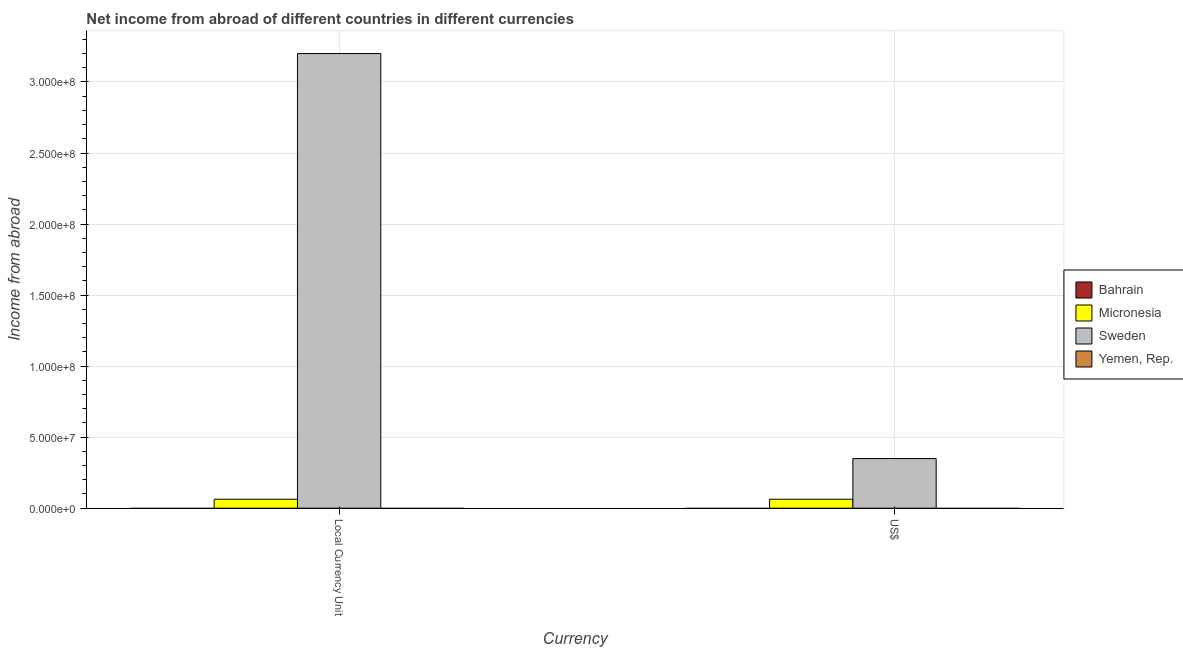How many different coloured bars are there?
Offer a very short reply. 2. How many groups of bars are there?
Offer a very short reply. 2. Are the number of bars on each tick of the X-axis equal?
Ensure brevity in your answer.  Yes. What is the label of the 2nd group of bars from the left?
Provide a short and direct response. US$. What is the income from abroad in constant 2005 us$ in Sweden?
Offer a terse response. 3.20e+08. Across all countries, what is the maximum income from abroad in constant 2005 us$?
Make the answer very short. 3.20e+08. Across all countries, what is the minimum income from abroad in constant 2005 us$?
Your answer should be very brief. 0. In which country was the income from abroad in us$ maximum?
Keep it short and to the point. Sweden. What is the total income from abroad in us$ in the graph?
Your answer should be very brief. 4.12e+07. What is the difference between the income from abroad in us$ in Micronesia and that in Sweden?
Provide a short and direct response. -2.86e+07. What is the average income from abroad in constant 2005 us$ per country?
Your response must be concise. 8.16e+07. What is the difference between the income from abroad in us$ and income from abroad in constant 2005 us$ in Micronesia?
Ensure brevity in your answer.  0. Is the income from abroad in us$ in Micronesia less than that in Sweden?
Your response must be concise. Yes. In how many countries, is the income from abroad in us$ greater than the average income from abroad in us$ taken over all countries?
Provide a succinct answer. 1. How many countries are there in the graph?
Your answer should be compact. 4. What is the difference between two consecutive major ticks on the Y-axis?
Make the answer very short. 5.00e+07. Does the graph contain grids?
Provide a short and direct response. Yes. How are the legend labels stacked?
Make the answer very short. Vertical. What is the title of the graph?
Your answer should be very brief. Net income from abroad of different countries in different currencies. What is the label or title of the X-axis?
Keep it short and to the point. Currency. What is the label or title of the Y-axis?
Provide a short and direct response. Income from abroad. What is the Income from abroad of Micronesia in Local Currency Unit?
Provide a succinct answer. 6.31e+06. What is the Income from abroad in Sweden in Local Currency Unit?
Provide a succinct answer. 3.20e+08. What is the Income from abroad in Bahrain in US$?
Keep it short and to the point. 0. What is the Income from abroad of Micronesia in US$?
Keep it short and to the point. 6.31e+06. What is the Income from abroad of Sweden in US$?
Offer a terse response. 3.49e+07. What is the Income from abroad in Yemen, Rep. in US$?
Your response must be concise. 0. Across all Currency, what is the maximum Income from abroad of Micronesia?
Make the answer very short. 6.31e+06. Across all Currency, what is the maximum Income from abroad of Sweden?
Provide a short and direct response. 3.20e+08. Across all Currency, what is the minimum Income from abroad in Micronesia?
Your answer should be very brief. 6.31e+06. Across all Currency, what is the minimum Income from abroad of Sweden?
Your answer should be very brief. 3.49e+07. What is the total Income from abroad of Bahrain in the graph?
Keep it short and to the point. 0. What is the total Income from abroad in Micronesia in the graph?
Provide a succinct answer. 1.26e+07. What is the total Income from abroad of Sweden in the graph?
Offer a terse response. 3.55e+08. What is the total Income from abroad in Yemen, Rep. in the graph?
Offer a terse response. 0. What is the difference between the Income from abroad of Sweden in Local Currency Unit and that in US$?
Ensure brevity in your answer.  2.85e+08. What is the difference between the Income from abroad in Micronesia in Local Currency Unit and the Income from abroad in Sweden in US$?
Keep it short and to the point. -2.86e+07. What is the average Income from abroad in Bahrain per Currency?
Your answer should be very brief. 0. What is the average Income from abroad of Micronesia per Currency?
Keep it short and to the point. 6.31e+06. What is the average Income from abroad of Sweden per Currency?
Your response must be concise. 1.77e+08. What is the average Income from abroad in Yemen, Rep. per Currency?
Give a very brief answer. 0. What is the difference between the Income from abroad of Micronesia and Income from abroad of Sweden in Local Currency Unit?
Provide a short and direct response. -3.14e+08. What is the difference between the Income from abroad of Micronesia and Income from abroad of Sweden in US$?
Offer a terse response. -2.86e+07. What is the ratio of the Income from abroad in Sweden in Local Currency Unit to that in US$?
Provide a succinct answer. 9.16. What is the difference between the highest and the second highest Income from abroad of Sweden?
Offer a terse response. 2.85e+08. What is the difference between the highest and the lowest Income from abroad of Micronesia?
Your answer should be compact. 0. What is the difference between the highest and the lowest Income from abroad in Sweden?
Provide a succinct answer. 2.85e+08. 